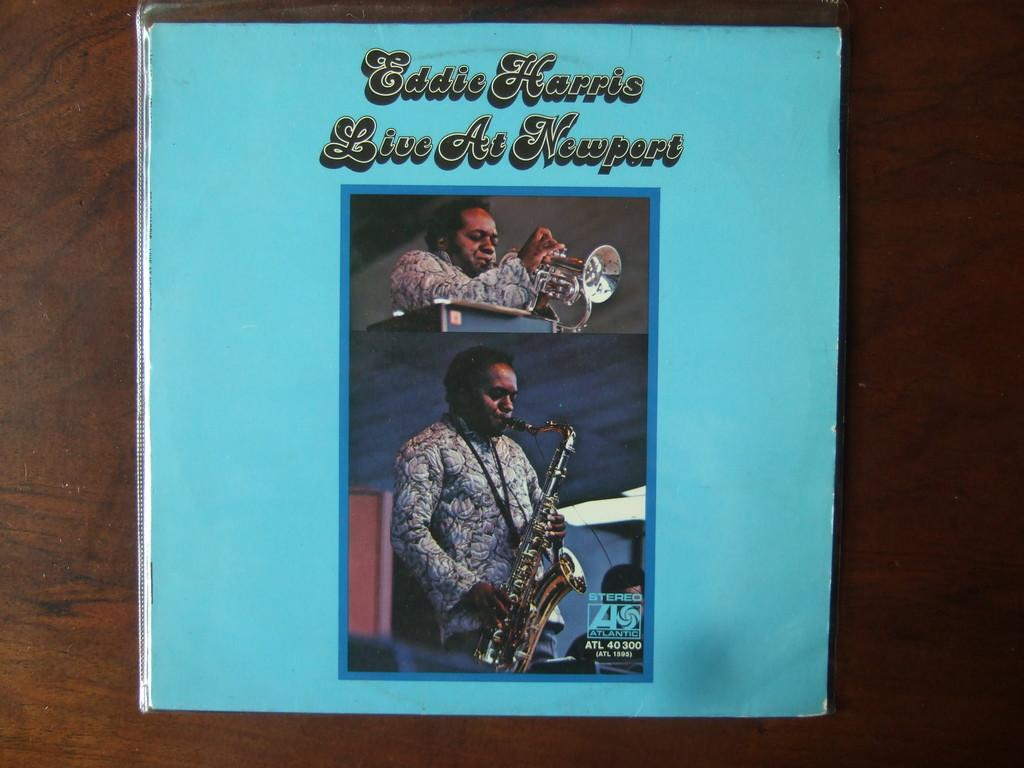<image>
Render a clear and concise summary of the photo. A brochure of Eddie Harris when he was performing at Newport. 